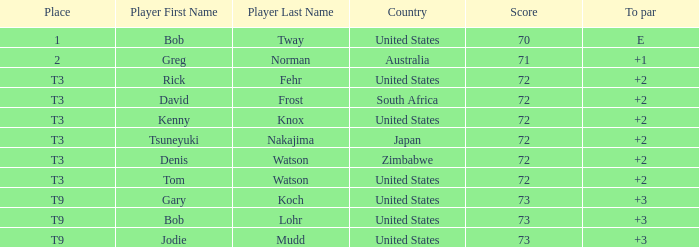Who scored more than 72? Gary Koch, Bob Lohr, Jodie Mudd. 